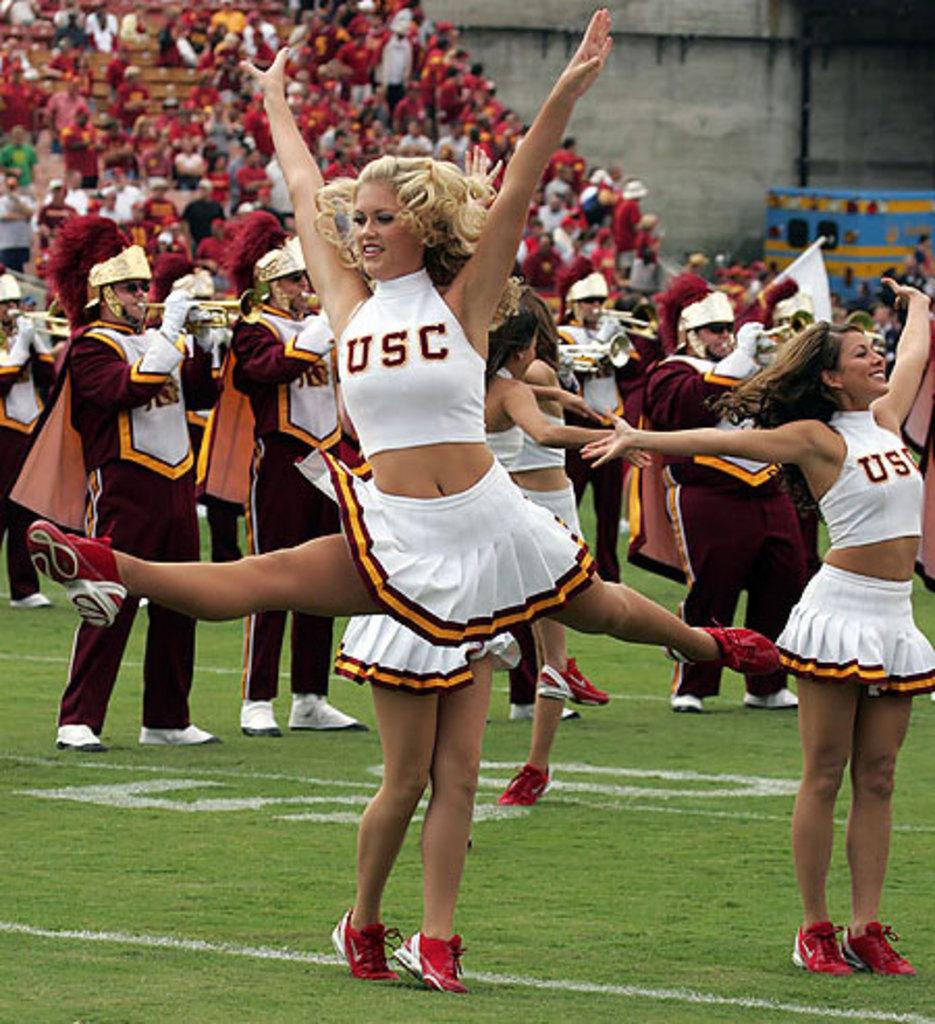What does the white  cheerleaders´  blouse say?
Your answer should be compact. Usc. 